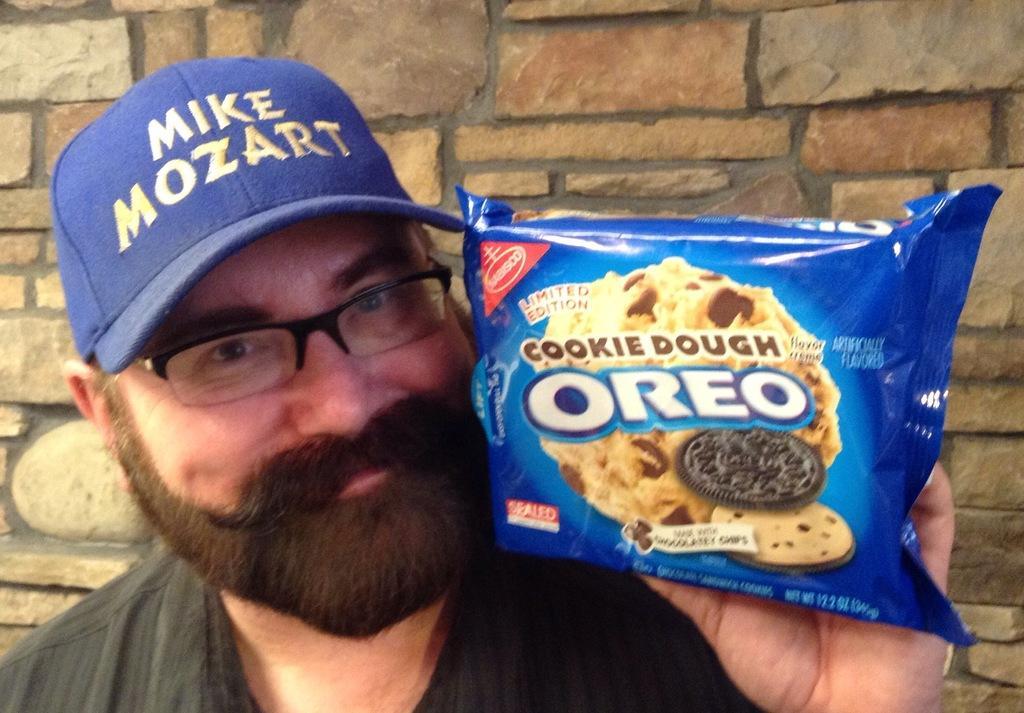Describe this image in one or two sentences. In the center of the image there is a person holding a biscuit packet in his hand. He is wearing a cap. In the background of the image there is wall. 